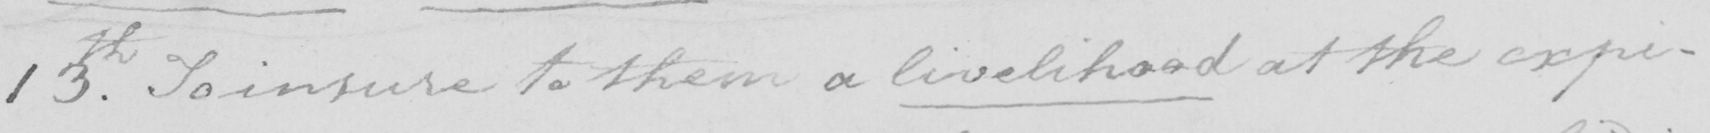Transcribe the text shown in this historical manuscript line. 13th . To insure to them a livelihood at the expi- 